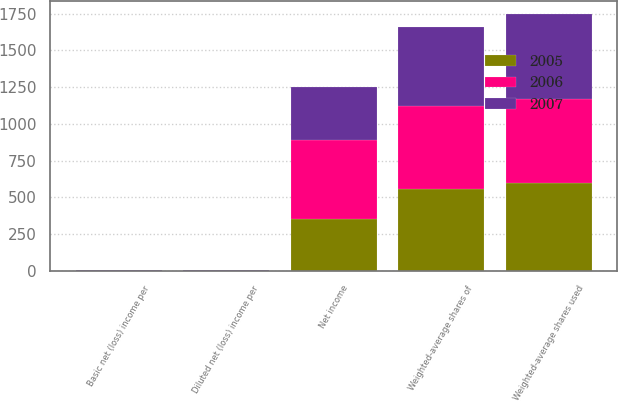Convert chart. <chart><loc_0><loc_0><loc_500><loc_500><stacked_bar_chart><ecel><fcel>Net income<fcel>Weighted-average shares of<fcel>Weighted-average shares used<fcel>Basic net (loss) income per<fcel>Diluted net (loss) income per<nl><fcel>2007<fcel>360.8<fcel>537.8<fcel>579.1<fcel>0.67<fcel>0.62<nl><fcel>2006<fcel>537.8<fcel>567.5<fcel>567.5<fcel>1.76<fcel>1.76<nl><fcel>2005<fcel>350.7<fcel>554.3<fcel>600.2<fcel>0.63<fcel>0.58<nl></chart> 